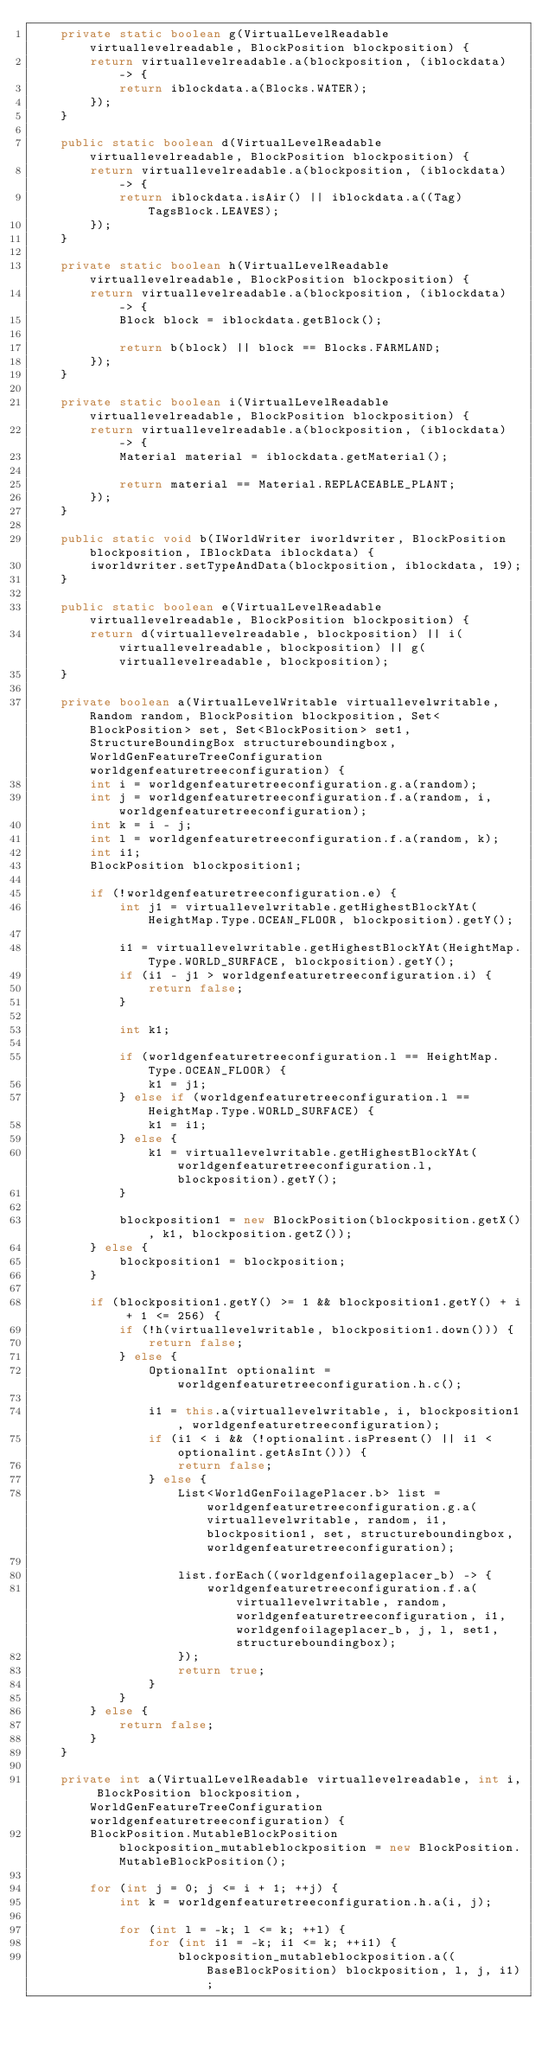Convert code to text. <code><loc_0><loc_0><loc_500><loc_500><_Java_>    private static boolean g(VirtualLevelReadable virtuallevelreadable, BlockPosition blockposition) {
        return virtuallevelreadable.a(blockposition, (iblockdata) -> {
            return iblockdata.a(Blocks.WATER);
        });
    }

    public static boolean d(VirtualLevelReadable virtuallevelreadable, BlockPosition blockposition) {
        return virtuallevelreadable.a(blockposition, (iblockdata) -> {
            return iblockdata.isAir() || iblockdata.a((Tag) TagsBlock.LEAVES);
        });
    }

    private static boolean h(VirtualLevelReadable virtuallevelreadable, BlockPosition blockposition) {
        return virtuallevelreadable.a(blockposition, (iblockdata) -> {
            Block block = iblockdata.getBlock();

            return b(block) || block == Blocks.FARMLAND;
        });
    }

    private static boolean i(VirtualLevelReadable virtuallevelreadable, BlockPosition blockposition) {
        return virtuallevelreadable.a(blockposition, (iblockdata) -> {
            Material material = iblockdata.getMaterial();

            return material == Material.REPLACEABLE_PLANT;
        });
    }

    public static void b(IWorldWriter iworldwriter, BlockPosition blockposition, IBlockData iblockdata) {
        iworldwriter.setTypeAndData(blockposition, iblockdata, 19);
    }

    public static boolean e(VirtualLevelReadable virtuallevelreadable, BlockPosition blockposition) {
        return d(virtuallevelreadable, blockposition) || i(virtuallevelreadable, blockposition) || g(virtuallevelreadable, blockposition);
    }

    private boolean a(VirtualLevelWritable virtuallevelwritable, Random random, BlockPosition blockposition, Set<BlockPosition> set, Set<BlockPosition> set1, StructureBoundingBox structureboundingbox, WorldGenFeatureTreeConfiguration worldgenfeaturetreeconfiguration) {
        int i = worldgenfeaturetreeconfiguration.g.a(random);
        int j = worldgenfeaturetreeconfiguration.f.a(random, i, worldgenfeaturetreeconfiguration);
        int k = i - j;
        int l = worldgenfeaturetreeconfiguration.f.a(random, k);
        int i1;
        BlockPosition blockposition1;

        if (!worldgenfeaturetreeconfiguration.e) {
            int j1 = virtuallevelwritable.getHighestBlockYAt(HeightMap.Type.OCEAN_FLOOR, blockposition).getY();

            i1 = virtuallevelwritable.getHighestBlockYAt(HeightMap.Type.WORLD_SURFACE, blockposition).getY();
            if (i1 - j1 > worldgenfeaturetreeconfiguration.i) {
                return false;
            }

            int k1;

            if (worldgenfeaturetreeconfiguration.l == HeightMap.Type.OCEAN_FLOOR) {
                k1 = j1;
            } else if (worldgenfeaturetreeconfiguration.l == HeightMap.Type.WORLD_SURFACE) {
                k1 = i1;
            } else {
                k1 = virtuallevelwritable.getHighestBlockYAt(worldgenfeaturetreeconfiguration.l, blockposition).getY();
            }

            blockposition1 = new BlockPosition(blockposition.getX(), k1, blockposition.getZ());
        } else {
            blockposition1 = blockposition;
        }

        if (blockposition1.getY() >= 1 && blockposition1.getY() + i + 1 <= 256) {
            if (!h(virtuallevelwritable, blockposition1.down())) {
                return false;
            } else {
                OptionalInt optionalint = worldgenfeaturetreeconfiguration.h.c();

                i1 = this.a(virtuallevelwritable, i, blockposition1, worldgenfeaturetreeconfiguration);
                if (i1 < i && (!optionalint.isPresent() || i1 < optionalint.getAsInt())) {
                    return false;
                } else {
                    List<WorldGenFoilagePlacer.b> list = worldgenfeaturetreeconfiguration.g.a(virtuallevelwritable, random, i1, blockposition1, set, structureboundingbox, worldgenfeaturetreeconfiguration);

                    list.forEach((worldgenfoilageplacer_b) -> {
                        worldgenfeaturetreeconfiguration.f.a(virtuallevelwritable, random, worldgenfeaturetreeconfiguration, i1, worldgenfoilageplacer_b, j, l, set1, structureboundingbox);
                    });
                    return true;
                }
            }
        } else {
            return false;
        }
    }

    private int a(VirtualLevelReadable virtuallevelreadable, int i, BlockPosition blockposition, WorldGenFeatureTreeConfiguration worldgenfeaturetreeconfiguration) {
        BlockPosition.MutableBlockPosition blockposition_mutableblockposition = new BlockPosition.MutableBlockPosition();

        for (int j = 0; j <= i + 1; ++j) {
            int k = worldgenfeaturetreeconfiguration.h.a(i, j);

            for (int l = -k; l <= k; ++l) {
                for (int i1 = -k; i1 <= k; ++i1) {
                    blockposition_mutableblockposition.a((BaseBlockPosition) blockposition, l, j, i1);</code> 